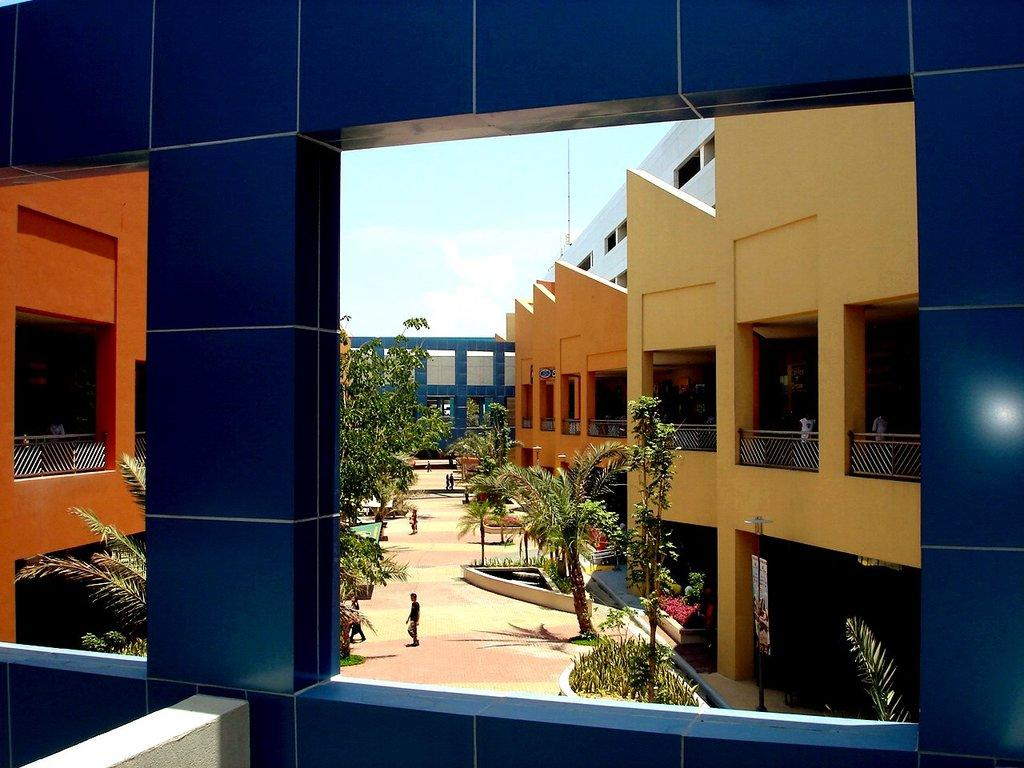What type of face can be seen on the buildings in the image? There are no faces on the buildings in the image; the buildings are inanimate structures. What type of thing is the fence in the image made of? The fact does not specify the material of the fence, so we cannot determine its composition from the given information. Are there any horses present in the image? No, there are no horses visible in the image. What color is the horse that is not present in the image? There is no horse present in the image, so we cannot determine its color. 